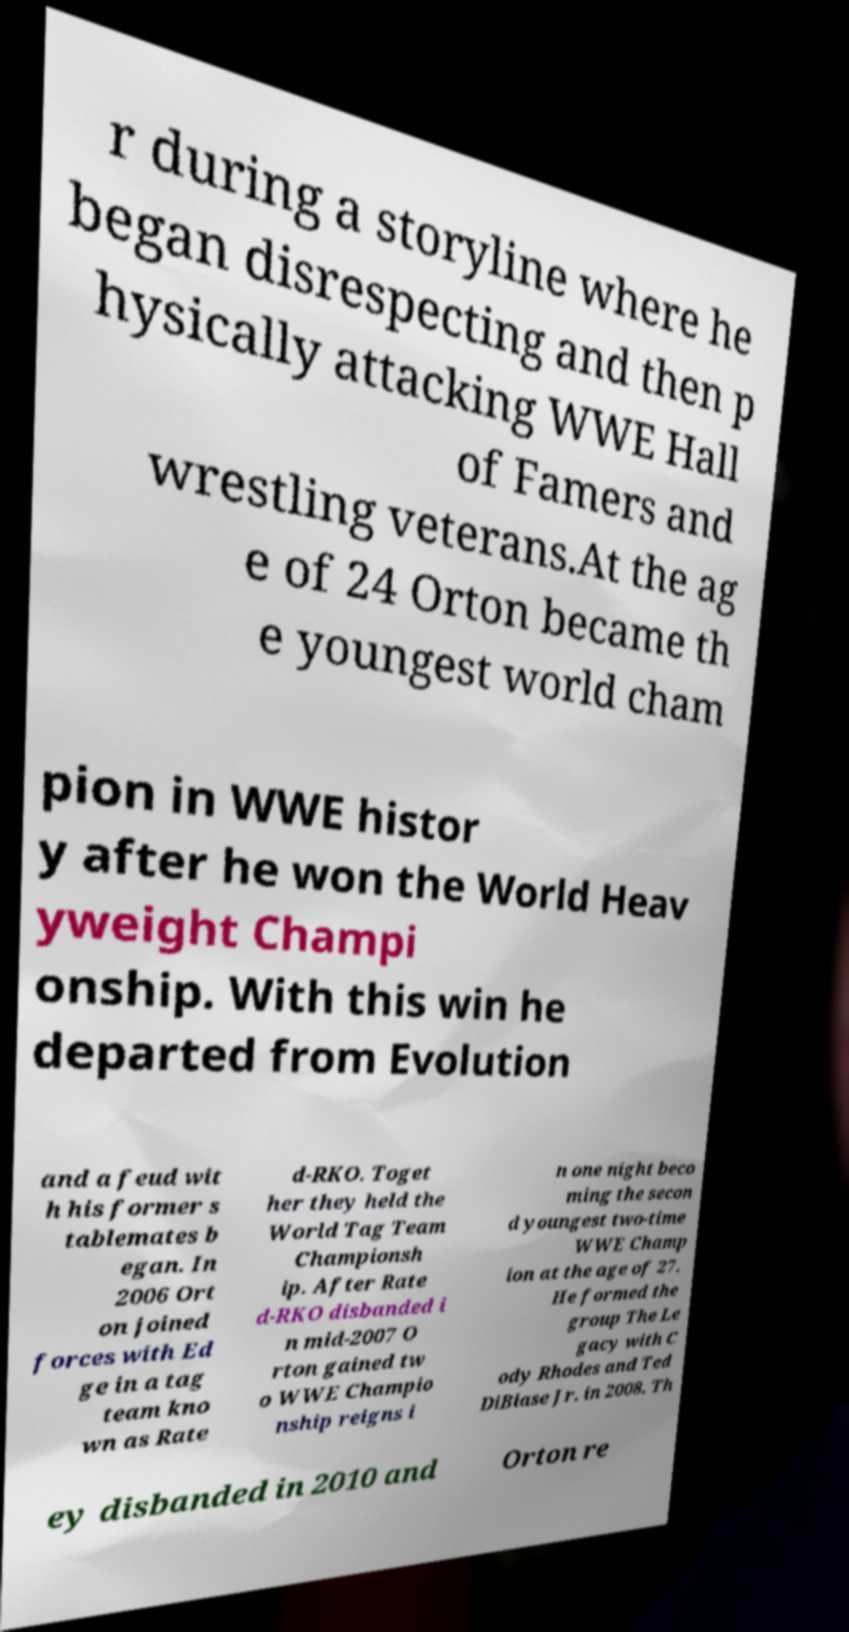Can you read and provide the text displayed in the image?This photo seems to have some interesting text. Can you extract and type it out for me? r during a storyline where he began disrespecting and then p hysically attacking WWE Hall of Famers and wrestling veterans.At the ag e of 24 Orton became th e youngest world cham pion in WWE histor y after he won the World Heav yweight Champi onship. With this win he departed from Evolution and a feud wit h his former s tablemates b egan. In 2006 Ort on joined forces with Ed ge in a tag team kno wn as Rate d-RKO. Toget her they held the World Tag Team Championsh ip. After Rate d-RKO disbanded i n mid-2007 O rton gained tw o WWE Champio nship reigns i n one night beco ming the secon d youngest two-time WWE Champ ion at the age of 27. He formed the group The Le gacy with C ody Rhodes and Ted DiBiase Jr. in 2008. Th ey disbanded in 2010 and Orton re 